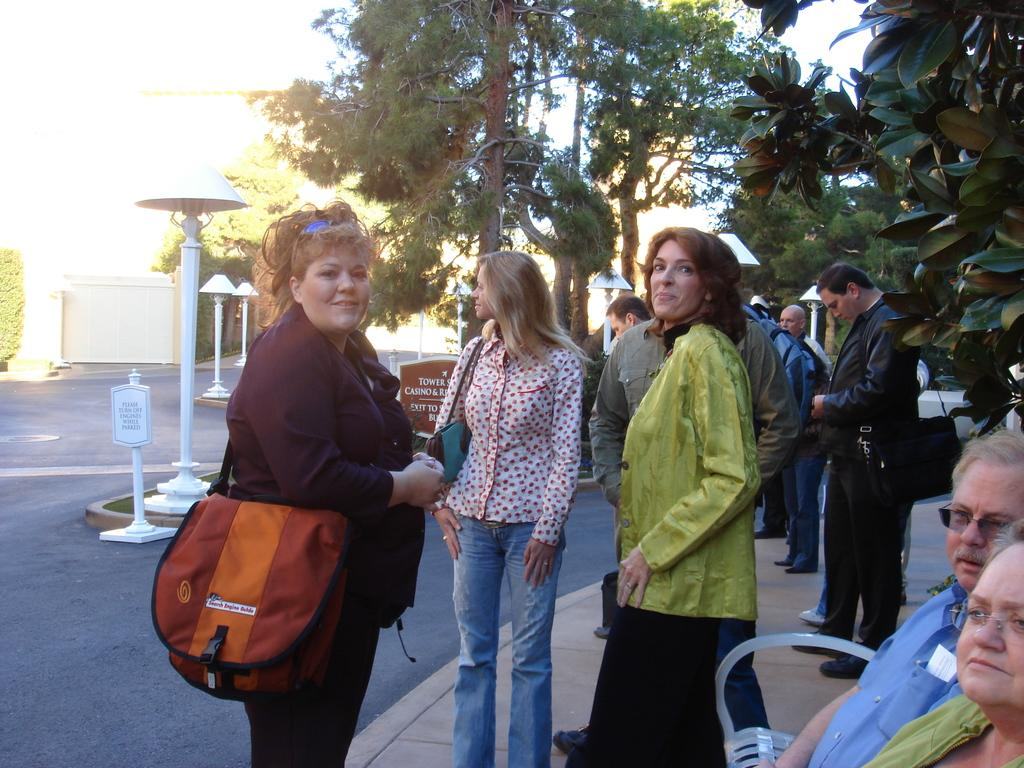What can be observed about the people in the image? There are people standing in the image. Can you describe the lady among the people? The lady is wearing a backpack. What can be seen in the background of the image? There are trees and poles visible in the background. What type of agreement is being discussed by the people in the image? There is no indication in the image that the people are discussing any agreements. Can you see any bones in the image? There are no bones visible in the image. 